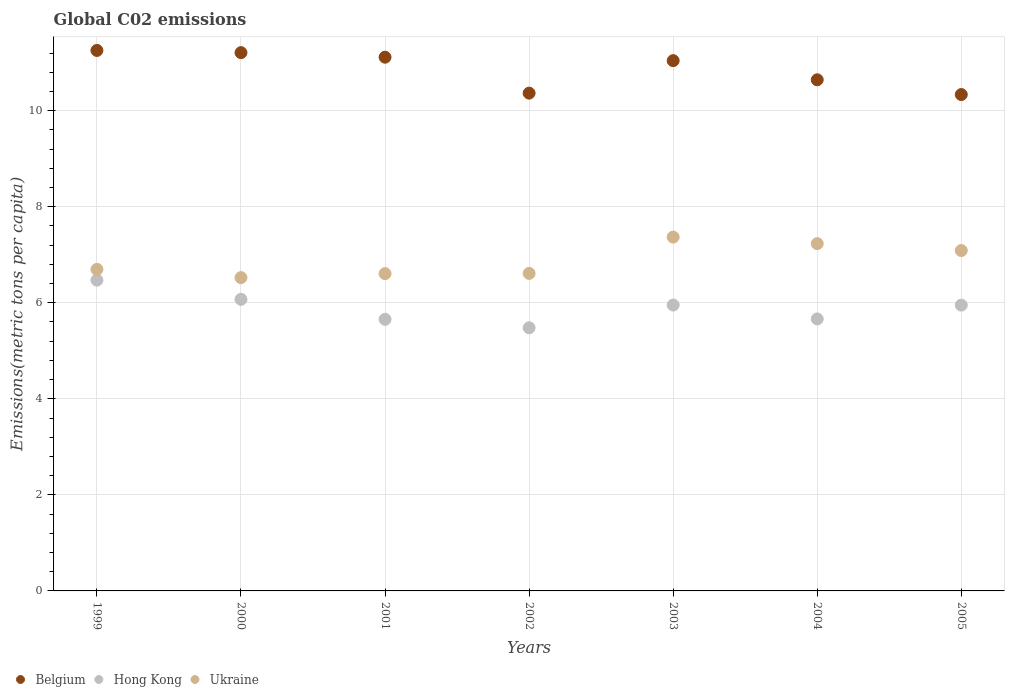How many different coloured dotlines are there?
Provide a succinct answer. 3. What is the amount of CO2 emitted in in Hong Kong in 2002?
Provide a succinct answer. 5.48. Across all years, what is the maximum amount of CO2 emitted in in Belgium?
Ensure brevity in your answer.  11.25. Across all years, what is the minimum amount of CO2 emitted in in Ukraine?
Your answer should be very brief. 6.52. In which year was the amount of CO2 emitted in in Belgium maximum?
Offer a terse response. 1999. What is the total amount of CO2 emitted in in Ukraine in the graph?
Your response must be concise. 48.12. What is the difference between the amount of CO2 emitted in in Belgium in 2000 and that in 2003?
Your answer should be very brief. 0.17. What is the difference between the amount of CO2 emitted in in Hong Kong in 2004 and the amount of CO2 emitted in in Belgium in 2001?
Offer a very short reply. -5.45. What is the average amount of CO2 emitted in in Hong Kong per year?
Ensure brevity in your answer.  5.89. In the year 2004, what is the difference between the amount of CO2 emitted in in Hong Kong and amount of CO2 emitted in in Ukraine?
Make the answer very short. -1.57. What is the ratio of the amount of CO2 emitted in in Ukraine in 1999 to that in 2003?
Your answer should be very brief. 0.91. Is the amount of CO2 emitted in in Ukraine in 2002 less than that in 2004?
Offer a very short reply. Yes. What is the difference between the highest and the second highest amount of CO2 emitted in in Ukraine?
Your response must be concise. 0.14. What is the difference between the highest and the lowest amount of CO2 emitted in in Belgium?
Your answer should be very brief. 0.92. In how many years, is the amount of CO2 emitted in in Ukraine greater than the average amount of CO2 emitted in in Ukraine taken over all years?
Your answer should be very brief. 3. Is it the case that in every year, the sum of the amount of CO2 emitted in in Hong Kong and amount of CO2 emitted in in Belgium  is greater than the amount of CO2 emitted in in Ukraine?
Make the answer very short. Yes. Is the amount of CO2 emitted in in Ukraine strictly less than the amount of CO2 emitted in in Belgium over the years?
Give a very brief answer. Yes. How many dotlines are there?
Your answer should be very brief. 3. What is the difference between two consecutive major ticks on the Y-axis?
Provide a succinct answer. 2. Are the values on the major ticks of Y-axis written in scientific E-notation?
Ensure brevity in your answer.  No. Does the graph contain any zero values?
Provide a succinct answer. No. How are the legend labels stacked?
Keep it short and to the point. Horizontal. What is the title of the graph?
Give a very brief answer. Global C02 emissions. Does "Low & middle income" appear as one of the legend labels in the graph?
Keep it short and to the point. No. What is the label or title of the X-axis?
Provide a succinct answer. Years. What is the label or title of the Y-axis?
Ensure brevity in your answer.  Emissions(metric tons per capita). What is the Emissions(metric tons per capita) in Belgium in 1999?
Offer a terse response. 11.25. What is the Emissions(metric tons per capita) in Hong Kong in 1999?
Make the answer very short. 6.47. What is the Emissions(metric tons per capita) of Ukraine in 1999?
Your response must be concise. 6.69. What is the Emissions(metric tons per capita) in Belgium in 2000?
Provide a succinct answer. 11.21. What is the Emissions(metric tons per capita) of Hong Kong in 2000?
Ensure brevity in your answer.  6.07. What is the Emissions(metric tons per capita) of Ukraine in 2000?
Ensure brevity in your answer.  6.52. What is the Emissions(metric tons per capita) in Belgium in 2001?
Offer a very short reply. 11.11. What is the Emissions(metric tons per capita) of Hong Kong in 2001?
Ensure brevity in your answer.  5.66. What is the Emissions(metric tons per capita) in Ukraine in 2001?
Make the answer very short. 6.61. What is the Emissions(metric tons per capita) in Belgium in 2002?
Offer a very short reply. 10.36. What is the Emissions(metric tons per capita) in Hong Kong in 2002?
Your response must be concise. 5.48. What is the Emissions(metric tons per capita) of Ukraine in 2002?
Provide a short and direct response. 6.61. What is the Emissions(metric tons per capita) in Belgium in 2003?
Your answer should be compact. 11.04. What is the Emissions(metric tons per capita) of Hong Kong in 2003?
Keep it short and to the point. 5.95. What is the Emissions(metric tons per capita) of Ukraine in 2003?
Your answer should be compact. 7.37. What is the Emissions(metric tons per capita) in Belgium in 2004?
Your response must be concise. 10.64. What is the Emissions(metric tons per capita) in Hong Kong in 2004?
Make the answer very short. 5.66. What is the Emissions(metric tons per capita) in Ukraine in 2004?
Offer a terse response. 7.23. What is the Emissions(metric tons per capita) in Belgium in 2005?
Your answer should be very brief. 10.34. What is the Emissions(metric tons per capita) in Hong Kong in 2005?
Make the answer very short. 5.95. What is the Emissions(metric tons per capita) in Ukraine in 2005?
Provide a short and direct response. 7.09. Across all years, what is the maximum Emissions(metric tons per capita) of Belgium?
Offer a very short reply. 11.25. Across all years, what is the maximum Emissions(metric tons per capita) of Hong Kong?
Make the answer very short. 6.47. Across all years, what is the maximum Emissions(metric tons per capita) of Ukraine?
Ensure brevity in your answer.  7.37. Across all years, what is the minimum Emissions(metric tons per capita) in Belgium?
Offer a terse response. 10.34. Across all years, what is the minimum Emissions(metric tons per capita) in Hong Kong?
Keep it short and to the point. 5.48. Across all years, what is the minimum Emissions(metric tons per capita) in Ukraine?
Your answer should be compact. 6.52. What is the total Emissions(metric tons per capita) in Belgium in the graph?
Make the answer very short. 75.96. What is the total Emissions(metric tons per capita) of Hong Kong in the graph?
Ensure brevity in your answer.  41.24. What is the total Emissions(metric tons per capita) of Ukraine in the graph?
Keep it short and to the point. 48.12. What is the difference between the Emissions(metric tons per capita) in Belgium in 1999 and that in 2000?
Offer a terse response. 0.05. What is the difference between the Emissions(metric tons per capita) of Hong Kong in 1999 and that in 2000?
Provide a short and direct response. 0.4. What is the difference between the Emissions(metric tons per capita) in Ukraine in 1999 and that in 2000?
Offer a very short reply. 0.17. What is the difference between the Emissions(metric tons per capita) of Belgium in 1999 and that in 2001?
Give a very brief answer. 0.14. What is the difference between the Emissions(metric tons per capita) in Hong Kong in 1999 and that in 2001?
Offer a terse response. 0.82. What is the difference between the Emissions(metric tons per capita) in Ukraine in 1999 and that in 2001?
Your answer should be very brief. 0.09. What is the difference between the Emissions(metric tons per capita) in Belgium in 1999 and that in 2002?
Keep it short and to the point. 0.89. What is the difference between the Emissions(metric tons per capita) of Ukraine in 1999 and that in 2002?
Give a very brief answer. 0.08. What is the difference between the Emissions(metric tons per capita) in Belgium in 1999 and that in 2003?
Make the answer very short. 0.21. What is the difference between the Emissions(metric tons per capita) of Hong Kong in 1999 and that in 2003?
Provide a short and direct response. 0.52. What is the difference between the Emissions(metric tons per capita) of Ukraine in 1999 and that in 2003?
Offer a terse response. -0.67. What is the difference between the Emissions(metric tons per capita) of Belgium in 1999 and that in 2004?
Your answer should be compact. 0.61. What is the difference between the Emissions(metric tons per capita) in Hong Kong in 1999 and that in 2004?
Give a very brief answer. 0.81. What is the difference between the Emissions(metric tons per capita) in Ukraine in 1999 and that in 2004?
Give a very brief answer. -0.54. What is the difference between the Emissions(metric tons per capita) in Belgium in 1999 and that in 2005?
Provide a short and direct response. 0.92. What is the difference between the Emissions(metric tons per capita) in Hong Kong in 1999 and that in 2005?
Your answer should be compact. 0.52. What is the difference between the Emissions(metric tons per capita) of Ukraine in 1999 and that in 2005?
Provide a succinct answer. -0.39. What is the difference between the Emissions(metric tons per capita) in Belgium in 2000 and that in 2001?
Your answer should be very brief. 0.09. What is the difference between the Emissions(metric tons per capita) of Hong Kong in 2000 and that in 2001?
Offer a terse response. 0.42. What is the difference between the Emissions(metric tons per capita) of Ukraine in 2000 and that in 2001?
Give a very brief answer. -0.08. What is the difference between the Emissions(metric tons per capita) in Belgium in 2000 and that in 2002?
Make the answer very short. 0.84. What is the difference between the Emissions(metric tons per capita) in Hong Kong in 2000 and that in 2002?
Provide a short and direct response. 0.59. What is the difference between the Emissions(metric tons per capita) in Ukraine in 2000 and that in 2002?
Make the answer very short. -0.09. What is the difference between the Emissions(metric tons per capita) of Belgium in 2000 and that in 2003?
Your answer should be very brief. 0.17. What is the difference between the Emissions(metric tons per capita) of Hong Kong in 2000 and that in 2003?
Your answer should be compact. 0.12. What is the difference between the Emissions(metric tons per capita) of Ukraine in 2000 and that in 2003?
Keep it short and to the point. -0.84. What is the difference between the Emissions(metric tons per capita) of Belgium in 2000 and that in 2004?
Give a very brief answer. 0.57. What is the difference between the Emissions(metric tons per capita) in Hong Kong in 2000 and that in 2004?
Make the answer very short. 0.41. What is the difference between the Emissions(metric tons per capita) in Ukraine in 2000 and that in 2004?
Provide a succinct answer. -0.71. What is the difference between the Emissions(metric tons per capita) in Belgium in 2000 and that in 2005?
Your answer should be compact. 0.87. What is the difference between the Emissions(metric tons per capita) in Hong Kong in 2000 and that in 2005?
Offer a terse response. 0.12. What is the difference between the Emissions(metric tons per capita) of Ukraine in 2000 and that in 2005?
Your answer should be compact. -0.56. What is the difference between the Emissions(metric tons per capita) of Belgium in 2001 and that in 2002?
Keep it short and to the point. 0.75. What is the difference between the Emissions(metric tons per capita) in Hong Kong in 2001 and that in 2002?
Provide a short and direct response. 0.18. What is the difference between the Emissions(metric tons per capita) in Ukraine in 2001 and that in 2002?
Your answer should be very brief. -0. What is the difference between the Emissions(metric tons per capita) in Belgium in 2001 and that in 2003?
Your answer should be very brief. 0.07. What is the difference between the Emissions(metric tons per capita) of Hong Kong in 2001 and that in 2003?
Your answer should be compact. -0.3. What is the difference between the Emissions(metric tons per capita) of Ukraine in 2001 and that in 2003?
Provide a succinct answer. -0.76. What is the difference between the Emissions(metric tons per capita) in Belgium in 2001 and that in 2004?
Offer a very short reply. 0.47. What is the difference between the Emissions(metric tons per capita) of Hong Kong in 2001 and that in 2004?
Your answer should be very brief. -0.01. What is the difference between the Emissions(metric tons per capita) in Ukraine in 2001 and that in 2004?
Your answer should be very brief. -0.62. What is the difference between the Emissions(metric tons per capita) in Belgium in 2001 and that in 2005?
Provide a short and direct response. 0.78. What is the difference between the Emissions(metric tons per capita) of Hong Kong in 2001 and that in 2005?
Ensure brevity in your answer.  -0.3. What is the difference between the Emissions(metric tons per capita) in Ukraine in 2001 and that in 2005?
Your answer should be compact. -0.48. What is the difference between the Emissions(metric tons per capita) in Belgium in 2002 and that in 2003?
Your answer should be compact. -0.68. What is the difference between the Emissions(metric tons per capita) of Hong Kong in 2002 and that in 2003?
Your answer should be compact. -0.47. What is the difference between the Emissions(metric tons per capita) of Ukraine in 2002 and that in 2003?
Provide a short and direct response. -0.76. What is the difference between the Emissions(metric tons per capita) in Belgium in 2002 and that in 2004?
Offer a terse response. -0.28. What is the difference between the Emissions(metric tons per capita) in Hong Kong in 2002 and that in 2004?
Make the answer very short. -0.18. What is the difference between the Emissions(metric tons per capita) of Ukraine in 2002 and that in 2004?
Your response must be concise. -0.62. What is the difference between the Emissions(metric tons per capita) in Belgium in 2002 and that in 2005?
Offer a terse response. 0.03. What is the difference between the Emissions(metric tons per capita) of Hong Kong in 2002 and that in 2005?
Provide a short and direct response. -0.47. What is the difference between the Emissions(metric tons per capita) of Ukraine in 2002 and that in 2005?
Offer a terse response. -0.48. What is the difference between the Emissions(metric tons per capita) of Belgium in 2003 and that in 2004?
Offer a very short reply. 0.4. What is the difference between the Emissions(metric tons per capita) of Hong Kong in 2003 and that in 2004?
Provide a short and direct response. 0.29. What is the difference between the Emissions(metric tons per capita) of Ukraine in 2003 and that in 2004?
Make the answer very short. 0.14. What is the difference between the Emissions(metric tons per capita) of Belgium in 2003 and that in 2005?
Offer a very short reply. 0.71. What is the difference between the Emissions(metric tons per capita) in Hong Kong in 2003 and that in 2005?
Give a very brief answer. 0. What is the difference between the Emissions(metric tons per capita) in Ukraine in 2003 and that in 2005?
Your answer should be very brief. 0.28. What is the difference between the Emissions(metric tons per capita) of Belgium in 2004 and that in 2005?
Make the answer very short. 0.31. What is the difference between the Emissions(metric tons per capita) of Hong Kong in 2004 and that in 2005?
Ensure brevity in your answer.  -0.29. What is the difference between the Emissions(metric tons per capita) of Ukraine in 2004 and that in 2005?
Your answer should be very brief. 0.14. What is the difference between the Emissions(metric tons per capita) in Belgium in 1999 and the Emissions(metric tons per capita) in Hong Kong in 2000?
Provide a succinct answer. 5.18. What is the difference between the Emissions(metric tons per capita) of Belgium in 1999 and the Emissions(metric tons per capita) of Ukraine in 2000?
Offer a terse response. 4.73. What is the difference between the Emissions(metric tons per capita) in Hong Kong in 1999 and the Emissions(metric tons per capita) in Ukraine in 2000?
Ensure brevity in your answer.  -0.05. What is the difference between the Emissions(metric tons per capita) of Belgium in 1999 and the Emissions(metric tons per capita) of Hong Kong in 2001?
Provide a succinct answer. 5.6. What is the difference between the Emissions(metric tons per capita) in Belgium in 1999 and the Emissions(metric tons per capita) in Ukraine in 2001?
Your answer should be compact. 4.65. What is the difference between the Emissions(metric tons per capita) in Hong Kong in 1999 and the Emissions(metric tons per capita) in Ukraine in 2001?
Give a very brief answer. -0.14. What is the difference between the Emissions(metric tons per capita) in Belgium in 1999 and the Emissions(metric tons per capita) in Hong Kong in 2002?
Provide a short and direct response. 5.77. What is the difference between the Emissions(metric tons per capita) in Belgium in 1999 and the Emissions(metric tons per capita) in Ukraine in 2002?
Offer a very short reply. 4.64. What is the difference between the Emissions(metric tons per capita) in Hong Kong in 1999 and the Emissions(metric tons per capita) in Ukraine in 2002?
Give a very brief answer. -0.14. What is the difference between the Emissions(metric tons per capita) in Belgium in 1999 and the Emissions(metric tons per capita) in Hong Kong in 2003?
Provide a succinct answer. 5.3. What is the difference between the Emissions(metric tons per capita) of Belgium in 1999 and the Emissions(metric tons per capita) of Ukraine in 2003?
Offer a terse response. 3.89. What is the difference between the Emissions(metric tons per capita) of Hong Kong in 1999 and the Emissions(metric tons per capita) of Ukraine in 2003?
Give a very brief answer. -0.9. What is the difference between the Emissions(metric tons per capita) in Belgium in 1999 and the Emissions(metric tons per capita) in Hong Kong in 2004?
Your answer should be very brief. 5.59. What is the difference between the Emissions(metric tons per capita) in Belgium in 1999 and the Emissions(metric tons per capita) in Ukraine in 2004?
Your answer should be compact. 4.02. What is the difference between the Emissions(metric tons per capita) in Hong Kong in 1999 and the Emissions(metric tons per capita) in Ukraine in 2004?
Provide a succinct answer. -0.76. What is the difference between the Emissions(metric tons per capita) in Belgium in 1999 and the Emissions(metric tons per capita) in Hong Kong in 2005?
Provide a short and direct response. 5.3. What is the difference between the Emissions(metric tons per capita) in Belgium in 1999 and the Emissions(metric tons per capita) in Ukraine in 2005?
Provide a short and direct response. 4.17. What is the difference between the Emissions(metric tons per capita) of Hong Kong in 1999 and the Emissions(metric tons per capita) of Ukraine in 2005?
Keep it short and to the point. -0.62. What is the difference between the Emissions(metric tons per capita) of Belgium in 2000 and the Emissions(metric tons per capita) of Hong Kong in 2001?
Ensure brevity in your answer.  5.55. What is the difference between the Emissions(metric tons per capita) in Belgium in 2000 and the Emissions(metric tons per capita) in Ukraine in 2001?
Make the answer very short. 4.6. What is the difference between the Emissions(metric tons per capita) of Hong Kong in 2000 and the Emissions(metric tons per capita) of Ukraine in 2001?
Offer a very short reply. -0.54. What is the difference between the Emissions(metric tons per capita) in Belgium in 2000 and the Emissions(metric tons per capita) in Hong Kong in 2002?
Your answer should be compact. 5.73. What is the difference between the Emissions(metric tons per capita) of Belgium in 2000 and the Emissions(metric tons per capita) of Ukraine in 2002?
Your answer should be very brief. 4.6. What is the difference between the Emissions(metric tons per capita) of Hong Kong in 2000 and the Emissions(metric tons per capita) of Ukraine in 2002?
Provide a short and direct response. -0.54. What is the difference between the Emissions(metric tons per capita) of Belgium in 2000 and the Emissions(metric tons per capita) of Hong Kong in 2003?
Offer a terse response. 5.26. What is the difference between the Emissions(metric tons per capita) in Belgium in 2000 and the Emissions(metric tons per capita) in Ukraine in 2003?
Make the answer very short. 3.84. What is the difference between the Emissions(metric tons per capita) in Hong Kong in 2000 and the Emissions(metric tons per capita) in Ukraine in 2003?
Provide a succinct answer. -1.3. What is the difference between the Emissions(metric tons per capita) in Belgium in 2000 and the Emissions(metric tons per capita) in Hong Kong in 2004?
Your response must be concise. 5.54. What is the difference between the Emissions(metric tons per capita) in Belgium in 2000 and the Emissions(metric tons per capita) in Ukraine in 2004?
Ensure brevity in your answer.  3.98. What is the difference between the Emissions(metric tons per capita) of Hong Kong in 2000 and the Emissions(metric tons per capita) of Ukraine in 2004?
Your answer should be very brief. -1.16. What is the difference between the Emissions(metric tons per capita) of Belgium in 2000 and the Emissions(metric tons per capita) of Hong Kong in 2005?
Ensure brevity in your answer.  5.26. What is the difference between the Emissions(metric tons per capita) in Belgium in 2000 and the Emissions(metric tons per capita) in Ukraine in 2005?
Your answer should be compact. 4.12. What is the difference between the Emissions(metric tons per capita) in Hong Kong in 2000 and the Emissions(metric tons per capita) in Ukraine in 2005?
Keep it short and to the point. -1.02. What is the difference between the Emissions(metric tons per capita) in Belgium in 2001 and the Emissions(metric tons per capita) in Hong Kong in 2002?
Offer a terse response. 5.63. What is the difference between the Emissions(metric tons per capita) in Belgium in 2001 and the Emissions(metric tons per capita) in Ukraine in 2002?
Your answer should be very brief. 4.5. What is the difference between the Emissions(metric tons per capita) of Hong Kong in 2001 and the Emissions(metric tons per capita) of Ukraine in 2002?
Make the answer very short. -0.96. What is the difference between the Emissions(metric tons per capita) in Belgium in 2001 and the Emissions(metric tons per capita) in Hong Kong in 2003?
Your answer should be compact. 5.16. What is the difference between the Emissions(metric tons per capita) in Belgium in 2001 and the Emissions(metric tons per capita) in Ukraine in 2003?
Offer a terse response. 3.75. What is the difference between the Emissions(metric tons per capita) of Hong Kong in 2001 and the Emissions(metric tons per capita) of Ukraine in 2003?
Offer a terse response. -1.71. What is the difference between the Emissions(metric tons per capita) in Belgium in 2001 and the Emissions(metric tons per capita) in Hong Kong in 2004?
Your answer should be compact. 5.45. What is the difference between the Emissions(metric tons per capita) of Belgium in 2001 and the Emissions(metric tons per capita) of Ukraine in 2004?
Provide a succinct answer. 3.88. What is the difference between the Emissions(metric tons per capita) in Hong Kong in 2001 and the Emissions(metric tons per capita) in Ukraine in 2004?
Make the answer very short. -1.58. What is the difference between the Emissions(metric tons per capita) of Belgium in 2001 and the Emissions(metric tons per capita) of Hong Kong in 2005?
Ensure brevity in your answer.  5.16. What is the difference between the Emissions(metric tons per capita) of Belgium in 2001 and the Emissions(metric tons per capita) of Ukraine in 2005?
Offer a terse response. 4.03. What is the difference between the Emissions(metric tons per capita) of Hong Kong in 2001 and the Emissions(metric tons per capita) of Ukraine in 2005?
Provide a succinct answer. -1.43. What is the difference between the Emissions(metric tons per capita) in Belgium in 2002 and the Emissions(metric tons per capita) in Hong Kong in 2003?
Provide a succinct answer. 4.41. What is the difference between the Emissions(metric tons per capita) of Belgium in 2002 and the Emissions(metric tons per capita) of Ukraine in 2003?
Ensure brevity in your answer.  3. What is the difference between the Emissions(metric tons per capita) in Hong Kong in 2002 and the Emissions(metric tons per capita) in Ukraine in 2003?
Your response must be concise. -1.89. What is the difference between the Emissions(metric tons per capita) in Belgium in 2002 and the Emissions(metric tons per capita) in Hong Kong in 2004?
Make the answer very short. 4.7. What is the difference between the Emissions(metric tons per capita) in Belgium in 2002 and the Emissions(metric tons per capita) in Ukraine in 2004?
Ensure brevity in your answer.  3.13. What is the difference between the Emissions(metric tons per capita) of Hong Kong in 2002 and the Emissions(metric tons per capita) of Ukraine in 2004?
Provide a short and direct response. -1.75. What is the difference between the Emissions(metric tons per capita) in Belgium in 2002 and the Emissions(metric tons per capita) in Hong Kong in 2005?
Your response must be concise. 4.41. What is the difference between the Emissions(metric tons per capita) of Belgium in 2002 and the Emissions(metric tons per capita) of Ukraine in 2005?
Your answer should be compact. 3.28. What is the difference between the Emissions(metric tons per capita) in Hong Kong in 2002 and the Emissions(metric tons per capita) in Ukraine in 2005?
Give a very brief answer. -1.61. What is the difference between the Emissions(metric tons per capita) in Belgium in 2003 and the Emissions(metric tons per capita) in Hong Kong in 2004?
Make the answer very short. 5.38. What is the difference between the Emissions(metric tons per capita) in Belgium in 2003 and the Emissions(metric tons per capita) in Ukraine in 2004?
Provide a succinct answer. 3.81. What is the difference between the Emissions(metric tons per capita) of Hong Kong in 2003 and the Emissions(metric tons per capita) of Ukraine in 2004?
Give a very brief answer. -1.28. What is the difference between the Emissions(metric tons per capita) in Belgium in 2003 and the Emissions(metric tons per capita) in Hong Kong in 2005?
Give a very brief answer. 5.09. What is the difference between the Emissions(metric tons per capita) in Belgium in 2003 and the Emissions(metric tons per capita) in Ukraine in 2005?
Provide a succinct answer. 3.95. What is the difference between the Emissions(metric tons per capita) in Hong Kong in 2003 and the Emissions(metric tons per capita) in Ukraine in 2005?
Provide a short and direct response. -1.14. What is the difference between the Emissions(metric tons per capita) in Belgium in 2004 and the Emissions(metric tons per capita) in Hong Kong in 2005?
Offer a very short reply. 4.69. What is the difference between the Emissions(metric tons per capita) of Belgium in 2004 and the Emissions(metric tons per capita) of Ukraine in 2005?
Offer a very short reply. 3.55. What is the difference between the Emissions(metric tons per capita) in Hong Kong in 2004 and the Emissions(metric tons per capita) in Ukraine in 2005?
Offer a very short reply. -1.42. What is the average Emissions(metric tons per capita) of Belgium per year?
Your response must be concise. 10.85. What is the average Emissions(metric tons per capita) of Hong Kong per year?
Offer a terse response. 5.89. What is the average Emissions(metric tons per capita) of Ukraine per year?
Make the answer very short. 6.87. In the year 1999, what is the difference between the Emissions(metric tons per capita) in Belgium and Emissions(metric tons per capita) in Hong Kong?
Your answer should be very brief. 4.78. In the year 1999, what is the difference between the Emissions(metric tons per capita) of Belgium and Emissions(metric tons per capita) of Ukraine?
Give a very brief answer. 4.56. In the year 1999, what is the difference between the Emissions(metric tons per capita) in Hong Kong and Emissions(metric tons per capita) in Ukraine?
Ensure brevity in your answer.  -0.22. In the year 2000, what is the difference between the Emissions(metric tons per capita) of Belgium and Emissions(metric tons per capita) of Hong Kong?
Provide a short and direct response. 5.14. In the year 2000, what is the difference between the Emissions(metric tons per capita) in Belgium and Emissions(metric tons per capita) in Ukraine?
Give a very brief answer. 4.68. In the year 2000, what is the difference between the Emissions(metric tons per capita) of Hong Kong and Emissions(metric tons per capita) of Ukraine?
Offer a very short reply. -0.45. In the year 2001, what is the difference between the Emissions(metric tons per capita) of Belgium and Emissions(metric tons per capita) of Hong Kong?
Your answer should be very brief. 5.46. In the year 2001, what is the difference between the Emissions(metric tons per capita) of Belgium and Emissions(metric tons per capita) of Ukraine?
Make the answer very short. 4.51. In the year 2001, what is the difference between the Emissions(metric tons per capita) in Hong Kong and Emissions(metric tons per capita) in Ukraine?
Your answer should be very brief. -0.95. In the year 2002, what is the difference between the Emissions(metric tons per capita) in Belgium and Emissions(metric tons per capita) in Hong Kong?
Keep it short and to the point. 4.89. In the year 2002, what is the difference between the Emissions(metric tons per capita) in Belgium and Emissions(metric tons per capita) in Ukraine?
Your response must be concise. 3.75. In the year 2002, what is the difference between the Emissions(metric tons per capita) in Hong Kong and Emissions(metric tons per capita) in Ukraine?
Give a very brief answer. -1.13. In the year 2003, what is the difference between the Emissions(metric tons per capita) of Belgium and Emissions(metric tons per capita) of Hong Kong?
Keep it short and to the point. 5.09. In the year 2003, what is the difference between the Emissions(metric tons per capita) in Belgium and Emissions(metric tons per capita) in Ukraine?
Your answer should be compact. 3.67. In the year 2003, what is the difference between the Emissions(metric tons per capita) of Hong Kong and Emissions(metric tons per capita) of Ukraine?
Your answer should be very brief. -1.41. In the year 2004, what is the difference between the Emissions(metric tons per capita) of Belgium and Emissions(metric tons per capita) of Hong Kong?
Keep it short and to the point. 4.98. In the year 2004, what is the difference between the Emissions(metric tons per capita) in Belgium and Emissions(metric tons per capita) in Ukraine?
Keep it short and to the point. 3.41. In the year 2004, what is the difference between the Emissions(metric tons per capita) of Hong Kong and Emissions(metric tons per capita) of Ukraine?
Keep it short and to the point. -1.57. In the year 2005, what is the difference between the Emissions(metric tons per capita) of Belgium and Emissions(metric tons per capita) of Hong Kong?
Offer a very short reply. 4.38. In the year 2005, what is the difference between the Emissions(metric tons per capita) in Belgium and Emissions(metric tons per capita) in Ukraine?
Your answer should be compact. 3.25. In the year 2005, what is the difference between the Emissions(metric tons per capita) of Hong Kong and Emissions(metric tons per capita) of Ukraine?
Offer a terse response. -1.14. What is the ratio of the Emissions(metric tons per capita) in Hong Kong in 1999 to that in 2000?
Offer a very short reply. 1.07. What is the ratio of the Emissions(metric tons per capita) in Ukraine in 1999 to that in 2000?
Offer a very short reply. 1.03. What is the ratio of the Emissions(metric tons per capita) in Belgium in 1999 to that in 2001?
Offer a terse response. 1.01. What is the ratio of the Emissions(metric tons per capita) in Hong Kong in 1999 to that in 2001?
Offer a terse response. 1.14. What is the ratio of the Emissions(metric tons per capita) in Ukraine in 1999 to that in 2001?
Your response must be concise. 1.01. What is the ratio of the Emissions(metric tons per capita) of Belgium in 1999 to that in 2002?
Your answer should be very brief. 1.09. What is the ratio of the Emissions(metric tons per capita) of Hong Kong in 1999 to that in 2002?
Offer a terse response. 1.18. What is the ratio of the Emissions(metric tons per capita) in Ukraine in 1999 to that in 2002?
Your answer should be very brief. 1.01. What is the ratio of the Emissions(metric tons per capita) of Belgium in 1999 to that in 2003?
Your answer should be very brief. 1.02. What is the ratio of the Emissions(metric tons per capita) of Hong Kong in 1999 to that in 2003?
Your response must be concise. 1.09. What is the ratio of the Emissions(metric tons per capita) of Ukraine in 1999 to that in 2003?
Your answer should be very brief. 0.91. What is the ratio of the Emissions(metric tons per capita) in Belgium in 1999 to that in 2004?
Make the answer very short. 1.06. What is the ratio of the Emissions(metric tons per capita) of Hong Kong in 1999 to that in 2004?
Your answer should be compact. 1.14. What is the ratio of the Emissions(metric tons per capita) in Ukraine in 1999 to that in 2004?
Offer a terse response. 0.93. What is the ratio of the Emissions(metric tons per capita) of Belgium in 1999 to that in 2005?
Ensure brevity in your answer.  1.09. What is the ratio of the Emissions(metric tons per capita) of Hong Kong in 1999 to that in 2005?
Your response must be concise. 1.09. What is the ratio of the Emissions(metric tons per capita) in Ukraine in 1999 to that in 2005?
Provide a short and direct response. 0.94. What is the ratio of the Emissions(metric tons per capita) of Belgium in 2000 to that in 2001?
Offer a terse response. 1.01. What is the ratio of the Emissions(metric tons per capita) in Hong Kong in 2000 to that in 2001?
Offer a very short reply. 1.07. What is the ratio of the Emissions(metric tons per capita) of Ukraine in 2000 to that in 2001?
Provide a short and direct response. 0.99. What is the ratio of the Emissions(metric tons per capita) in Belgium in 2000 to that in 2002?
Offer a terse response. 1.08. What is the ratio of the Emissions(metric tons per capita) in Hong Kong in 2000 to that in 2002?
Make the answer very short. 1.11. What is the ratio of the Emissions(metric tons per capita) of Ukraine in 2000 to that in 2002?
Give a very brief answer. 0.99. What is the ratio of the Emissions(metric tons per capita) of Belgium in 2000 to that in 2003?
Provide a short and direct response. 1.02. What is the ratio of the Emissions(metric tons per capita) in Hong Kong in 2000 to that in 2003?
Your answer should be very brief. 1.02. What is the ratio of the Emissions(metric tons per capita) of Ukraine in 2000 to that in 2003?
Offer a very short reply. 0.89. What is the ratio of the Emissions(metric tons per capita) of Belgium in 2000 to that in 2004?
Your answer should be very brief. 1.05. What is the ratio of the Emissions(metric tons per capita) of Hong Kong in 2000 to that in 2004?
Ensure brevity in your answer.  1.07. What is the ratio of the Emissions(metric tons per capita) of Ukraine in 2000 to that in 2004?
Your response must be concise. 0.9. What is the ratio of the Emissions(metric tons per capita) of Belgium in 2000 to that in 2005?
Ensure brevity in your answer.  1.08. What is the ratio of the Emissions(metric tons per capita) in Hong Kong in 2000 to that in 2005?
Offer a terse response. 1.02. What is the ratio of the Emissions(metric tons per capita) in Ukraine in 2000 to that in 2005?
Give a very brief answer. 0.92. What is the ratio of the Emissions(metric tons per capita) in Belgium in 2001 to that in 2002?
Provide a short and direct response. 1.07. What is the ratio of the Emissions(metric tons per capita) of Hong Kong in 2001 to that in 2002?
Your answer should be compact. 1.03. What is the ratio of the Emissions(metric tons per capita) of Ukraine in 2001 to that in 2002?
Provide a short and direct response. 1. What is the ratio of the Emissions(metric tons per capita) in Belgium in 2001 to that in 2003?
Ensure brevity in your answer.  1.01. What is the ratio of the Emissions(metric tons per capita) of Hong Kong in 2001 to that in 2003?
Provide a succinct answer. 0.95. What is the ratio of the Emissions(metric tons per capita) in Ukraine in 2001 to that in 2003?
Provide a short and direct response. 0.9. What is the ratio of the Emissions(metric tons per capita) in Belgium in 2001 to that in 2004?
Offer a very short reply. 1.04. What is the ratio of the Emissions(metric tons per capita) of Hong Kong in 2001 to that in 2004?
Offer a terse response. 1. What is the ratio of the Emissions(metric tons per capita) of Ukraine in 2001 to that in 2004?
Give a very brief answer. 0.91. What is the ratio of the Emissions(metric tons per capita) in Belgium in 2001 to that in 2005?
Your answer should be compact. 1.08. What is the ratio of the Emissions(metric tons per capita) of Hong Kong in 2001 to that in 2005?
Keep it short and to the point. 0.95. What is the ratio of the Emissions(metric tons per capita) of Ukraine in 2001 to that in 2005?
Ensure brevity in your answer.  0.93. What is the ratio of the Emissions(metric tons per capita) in Belgium in 2002 to that in 2003?
Give a very brief answer. 0.94. What is the ratio of the Emissions(metric tons per capita) in Hong Kong in 2002 to that in 2003?
Keep it short and to the point. 0.92. What is the ratio of the Emissions(metric tons per capita) in Ukraine in 2002 to that in 2003?
Ensure brevity in your answer.  0.9. What is the ratio of the Emissions(metric tons per capita) of Belgium in 2002 to that in 2004?
Keep it short and to the point. 0.97. What is the ratio of the Emissions(metric tons per capita) of Hong Kong in 2002 to that in 2004?
Offer a very short reply. 0.97. What is the ratio of the Emissions(metric tons per capita) of Ukraine in 2002 to that in 2004?
Ensure brevity in your answer.  0.91. What is the ratio of the Emissions(metric tons per capita) of Belgium in 2002 to that in 2005?
Offer a very short reply. 1. What is the ratio of the Emissions(metric tons per capita) of Hong Kong in 2002 to that in 2005?
Your answer should be very brief. 0.92. What is the ratio of the Emissions(metric tons per capita) in Ukraine in 2002 to that in 2005?
Provide a short and direct response. 0.93. What is the ratio of the Emissions(metric tons per capita) in Belgium in 2003 to that in 2004?
Ensure brevity in your answer.  1.04. What is the ratio of the Emissions(metric tons per capita) of Hong Kong in 2003 to that in 2004?
Make the answer very short. 1.05. What is the ratio of the Emissions(metric tons per capita) in Ukraine in 2003 to that in 2004?
Offer a terse response. 1.02. What is the ratio of the Emissions(metric tons per capita) in Belgium in 2003 to that in 2005?
Offer a very short reply. 1.07. What is the ratio of the Emissions(metric tons per capita) of Hong Kong in 2003 to that in 2005?
Your answer should be very brief. 1. What is the ratio of the Emissions(metric tons per capita) of Ukraine in 2003 to that in 2005?
Offer a terse response. 1.04. What is the ratio of the Emissions(metric tons per capita) of Belgium in 2004 to that in 2005?
Provide a succinct answer. 1.03. What is the ratio of the Emissions(metric tons per capita) of Hong Kong in 2004 to that in 2005?
Your answer should be compact. 0.95. What is the ratio of the Emissions(metric tons per capita) in Ukraine in 2004 to that in 2005?
Make the answer very short. 1.02. What is the difference between the highest and the second highest Emissions(metric tons per capita) in Belgium?
Make the answer very short. 0.05. What is the difference between the highest and the second highest Emissions(metric tons per capita) of Hong Kong?
Keep it short and to the point. 0.4. What is the difference between the highest and the second highest Emissions(metric tons per capita) in Ukraine?
Your answer should be very brief. 0.14. What is the difference between the highest and the lowest Emissions(metric tons per capita) in Belgium?
Your response must be concise. 0.92. What is the difference between the highest and the lowest Emissions(metric tons per capita) in Hong Kong?
Provide a short and direct response. 0.99. What is the difference between the highest and the lowest Emissions(metric tons per capita) of Ukraine?
Your answer should be compact. 0.84. 